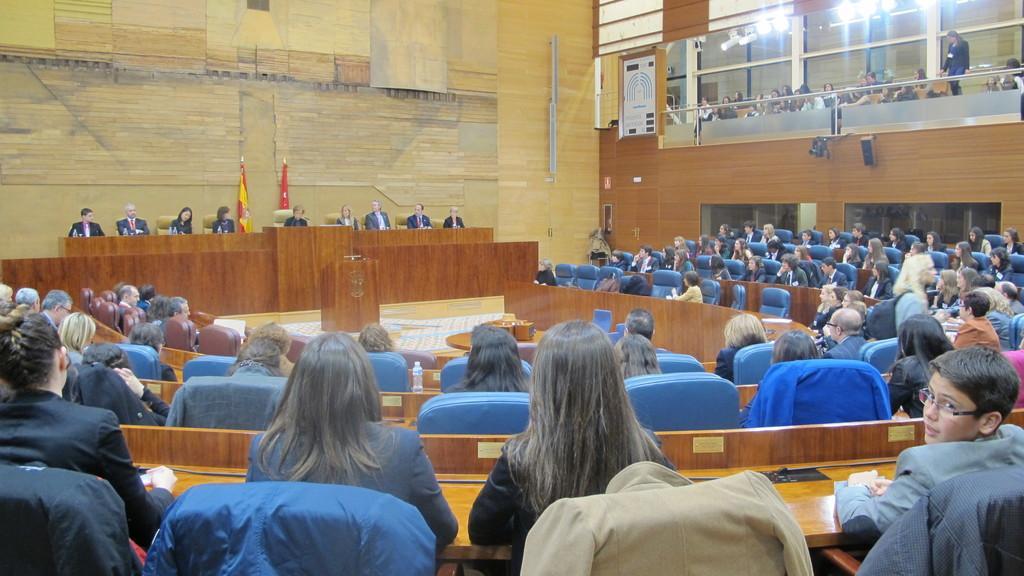How would you summarize this image in a sentence or two? There are group of people sitting on chairs and we can see objects on table. In the background we can see flags and wooden wall. On the right side of the image we can see lights and there is a person standing. 